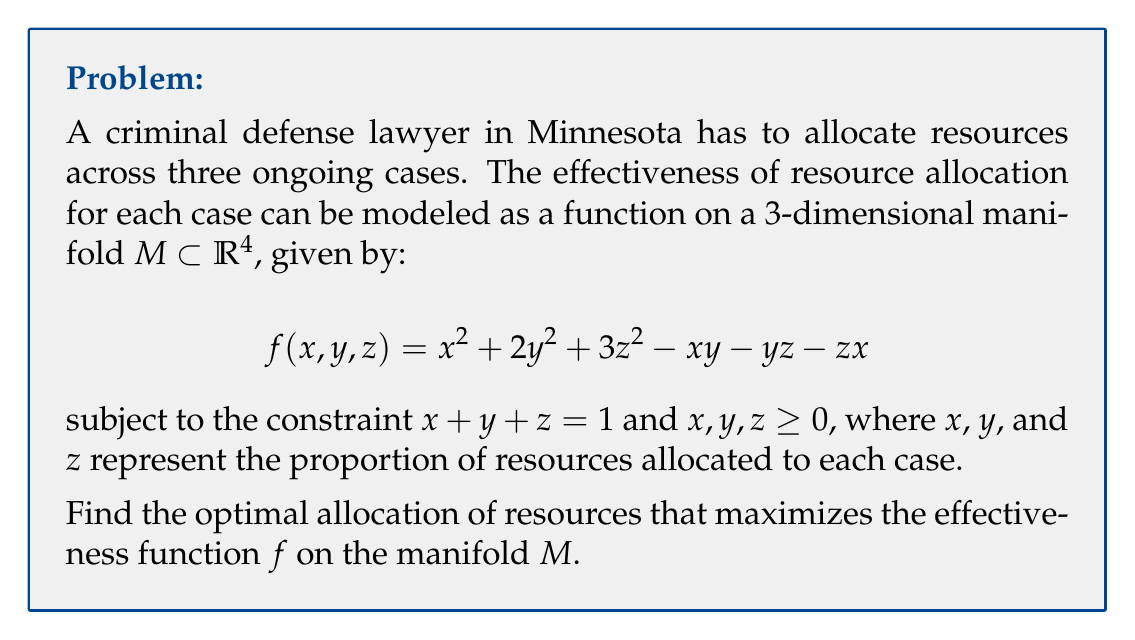Can you solve this math problem? To solve this optimization problem on the manifold $M$, we can use the method of Lagrange multipliers. Let's follow these steps:

1) First, we form the Lagrangian function:
   $$L(x, y, z, \lambda) = f(x, y, z) - \lambda(x + y + z - 1)$$
   $$L(x, y, z, \lambda) = x^2 + 2y^2 + 3z^2 - xy - yz - zx - \lambda(x + y + z - 1)$$

2) Now, we take partial derivatives and set them to zero:
   $$\frac{\partial L}{\partial x} = 2x - y - z - \lambda = 0$$
   $$\frac{\partial L}{\partial y} = 4y - x - z - \lambda = 0$$
   $$\frac{\partial L}{\partial z} = 6z - x - y - \lambda = 0$$
   $$\frac{\partial L}{\partial \lambda} = x + y + z - 1 = 0$$

3) From the first three equations:
   $$2x - y - z = \lambda$$
   $$4y - x - z = \lambda$$
   $$6z - x - y = \lambda$$

4) Subtracting the first equation from the second:
   $$3y = x \implies y = \frac{1}{3}x$$

5) Subtracting the first equation from the third:
   $$4z = 2x \implies z = \frac{1}{2}x$$

6) Substituting these into the constraint equation:
   $$x + \frac{1}{3}x + \frac{1}{2}x = 1$$
   $$\frac{11}{6}x = 1$$
   $$x = \frac{6}{11}$$

7) Therefore:
   $$y = \frac{1}{3} \cdot \frac{6}{11} = \frac{2}{11}$$
   $$z = \frac{1}{2} \cdot \frac{6}{11} = \frac{3}{11}$$

8) We can verify that this critical point is indeed a maximum by checking the second derivatives or by observing that it's the only critical point in the feasible region.
Answer: The optimal allocation of resources is:
Case 1: $\frac{6}{11}$ (approximately 54.5%)
Case 2: $\frac{2}{11}$ (approximately 18.2%)
Case 3: $\frac{3}{11}$ (approximately 27.3%) 